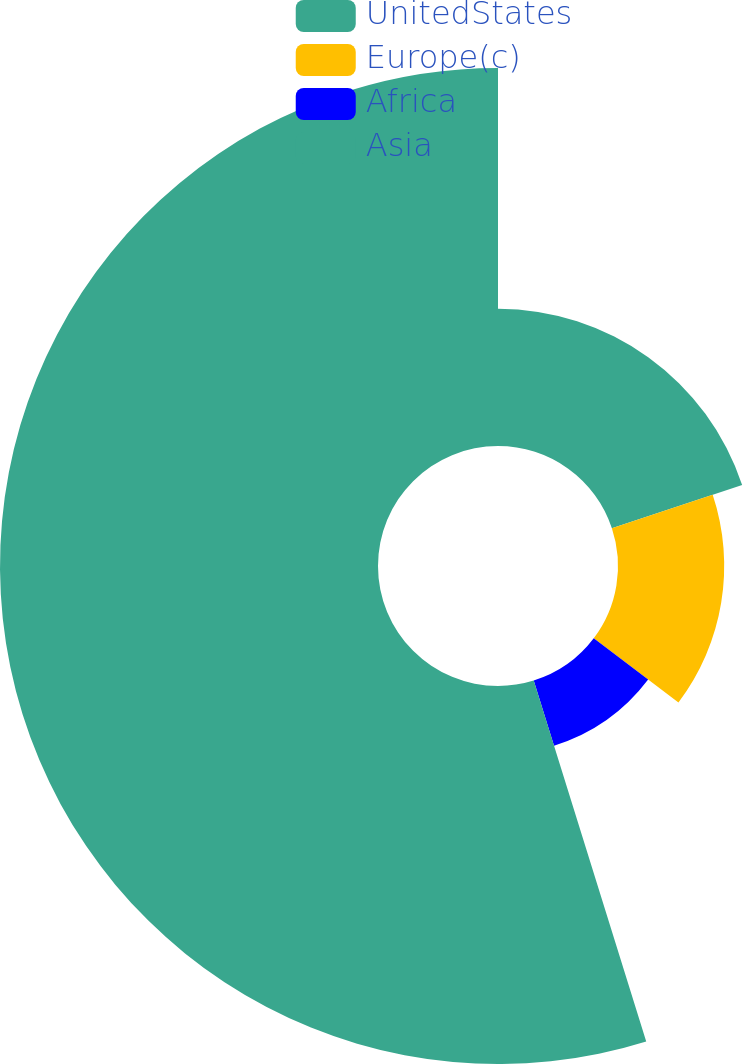Convert chart to OTSL. <chart><loc_0><loc_0><loc_500><loc_500><pie_chart><fcel>UnitedStates<fcel>Europe(c)<fcel>Africa<fcel>Asia<nl><fcel>19.9%<fcel>15.4%<fcel>9.89%<fcel>54.81%<nl></chart> 